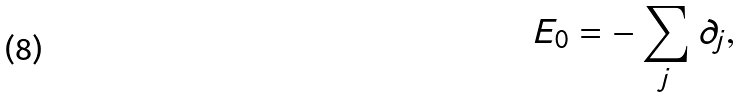<formula> <loc_0><loc_0><loc_500><loc_500>E _ { 0 } = - \sum _ { j } \partial _ { j } ,</formula> 